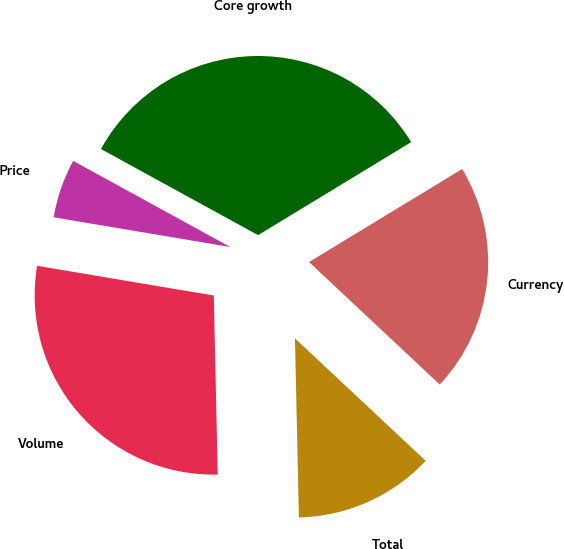<chart> <loc_0><loc_0><loc_500><loc_500><pie_chart><fcel>Volume<fcel>Price<fcel>Core growth<fcel>Currency<fcel>Total<nl><fcel>28.0%<fcel>5.33%<fcel>33.33%<fcel>20.67%<fcel>12.67%<nl></chart> 